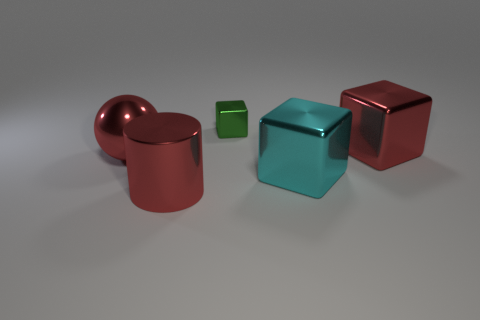What is the size of the red shiny object that is right of the cube on the left side of the large cyan shiny block?
Make the answer very short. Large. How many objects are both behind the red shiny cylinder and to the left of the tiny metallic block?
Offer a terse response. 1. There is a large block that is in front of the red metal thing that is right of the small green block; are there any tiny metal blocks to the right of it?
Keep it short and to the point. No. There is a cyan object that is the same size as the red sphere; what is its shape?
Ensure brevity in your answer.  Cube. Are there any big shiny cylinders of the same color as the small cube?
Your answer should be very brief. No. Is the shape of the tiny shiny thing the same as the big cyan object?
Ensure brevity in your answer.  Yes. What number of tiny things are either red blocks or red cylinders?
Your response must be concise. 0. There is a large sphere that is made of the same material as the big red cylinder; what is its color?
Ensure brevity in your answer.  Red. How many small blocks have the same material as the large cylinder?
Offer a very short reply. 1. There is a red object that is on the right side of the tiny green object; is its size the same as the green thing that is behind the big red cylinder?
Ensure brevity in your answer.  No. 